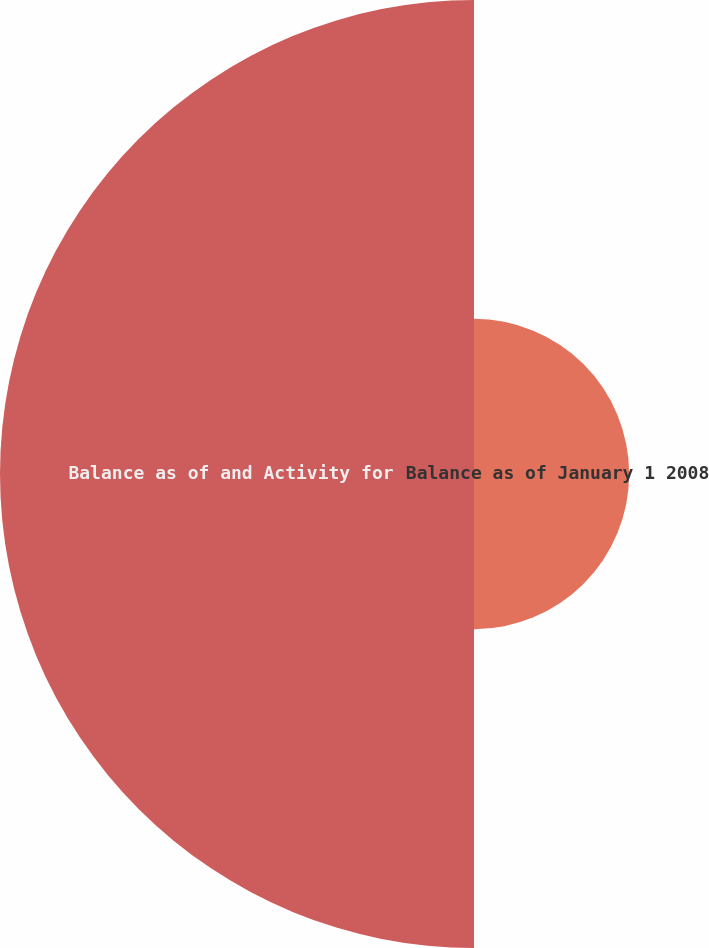Convert chart to OTSL. <chart><loc_0><loc_0><loc_500><loc_500><pie_chart><fcel>Balance as of January 1 2008<fcel>Balance as of and Activity for<nl><fcel>24.66%<fcel>75.34%<nl></chart> 